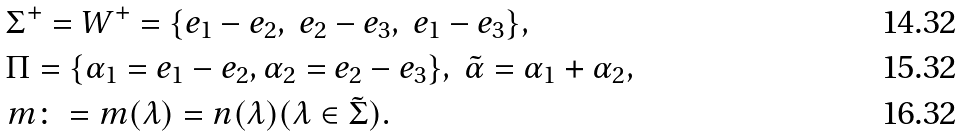<formula> <loc_0><loc_0><loc_500><loc_500>& \Sigma ^ { + } = W ^ { + } = \{ e _ { 1 } - e _ { 2 } , \ e _ { 2 } - e _ { 3 } , \ e _ { 1 } - e _ { 3 } \} , \\ & \Pi = \{ \alpha _ { 1 } = e _ { 1 } - e _ { 2 } , \alpha _ { 2 } = e _ { 2 } - e _ { 3 } \} , \ \tilde { \alpha } = \alpha _ { 1 } + \alpha _ { 2 } , \\ & m \colon = m ( \lambda ) = n ( \lambda ) ( \lambda \in \tilde { \Sigma } ) .</formula> 